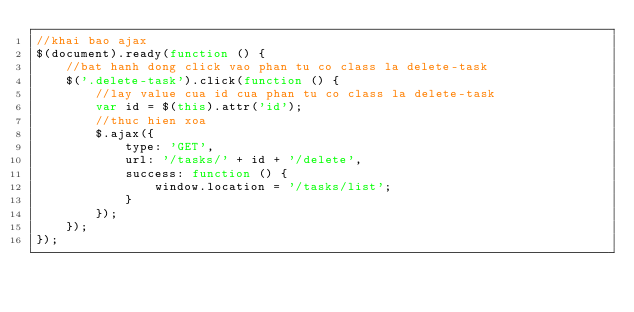<code> <loc_0><loc_0><loc_500><loc_500><_JavaScript_>//khai bao ajax
$(document).ready(function () {
    //bat hanh dong click vao phan tu co class la delete-task
    $('.delete-task').click(function () {
        //lay value cua id cua phan tu co class la delete-task
        var id = $(this).attr('id');
        //thuc hien xoa
        $.ajax({
            type: 'GET',
            url: '/tasks/' + id + '/delete',
            success: function () {
                window.location = '/tasks/list';
            }
        });
    });
});</code> 